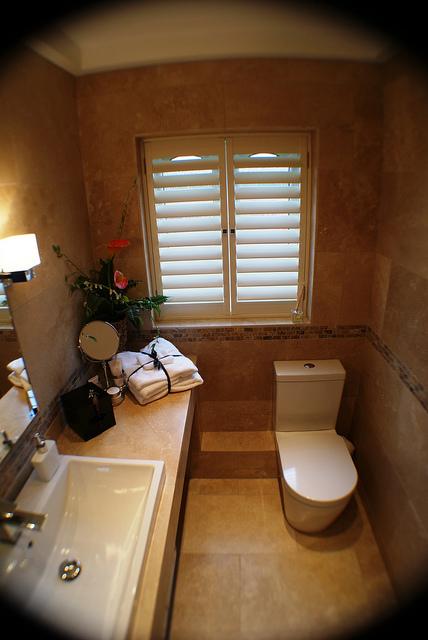Was this photographed with a wide-angle lens?
Keep it brief. Yes. How many toilets are there?
Answer briefly. 1. Is this a restroom for a large company?
Be succinct. No. Does the bathroom have wood floors?
Concise answer only. No. 